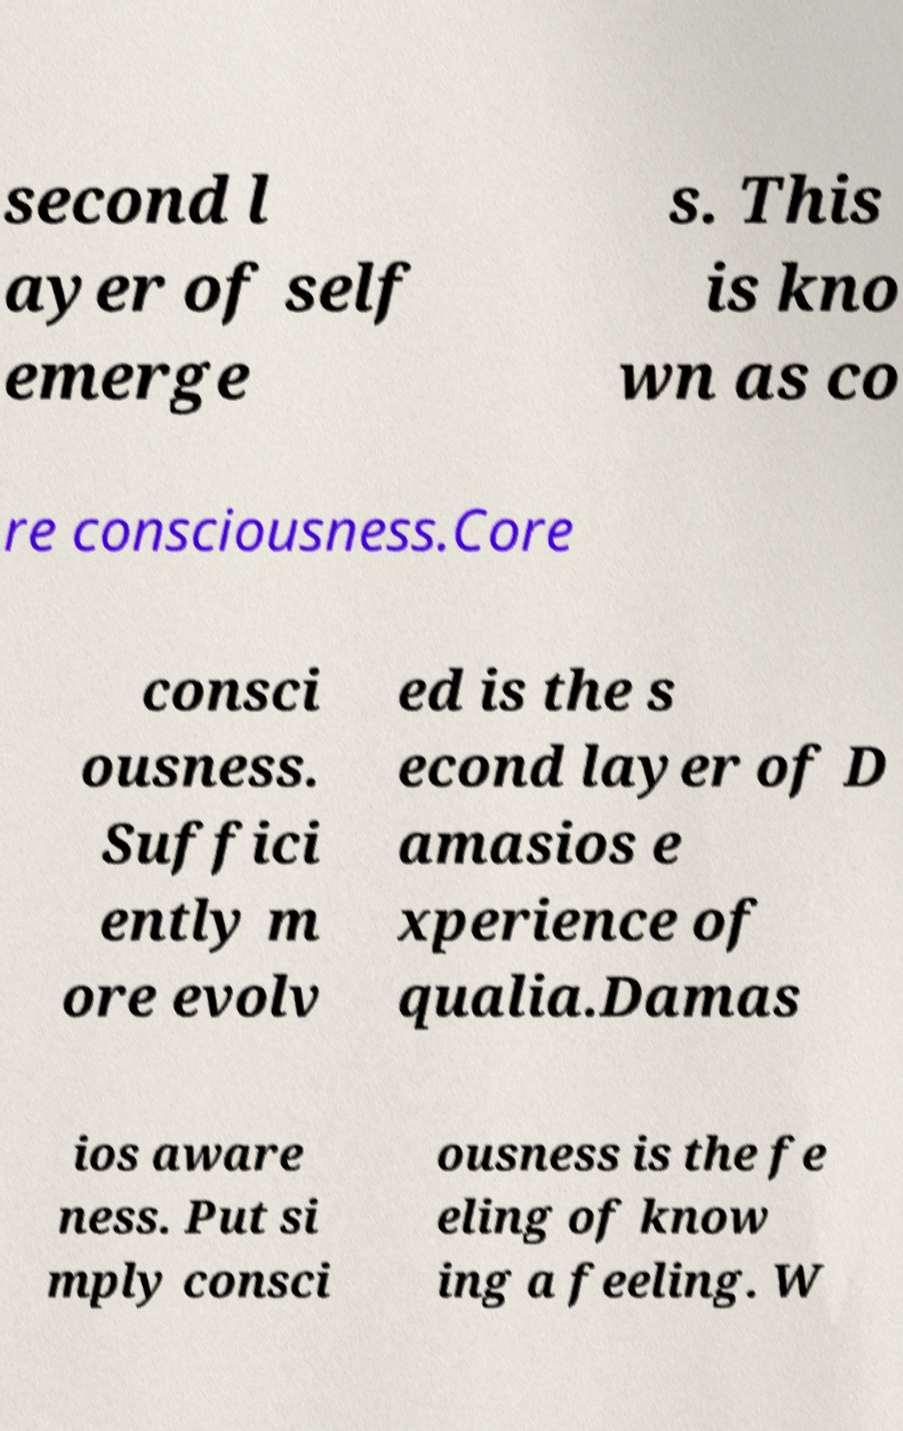Can you accurately transcribe the text from the provided image for me? second l ayer of self emerge s. This is kno wn as co re consciousness.Core consci ousness. Suffici ently m ore evolv ed is the s econd layer of D amasios e xperience of qualia.Damas ios aware ness. Put si mply consci ousness is the fe eling of know ing a feeling. W 